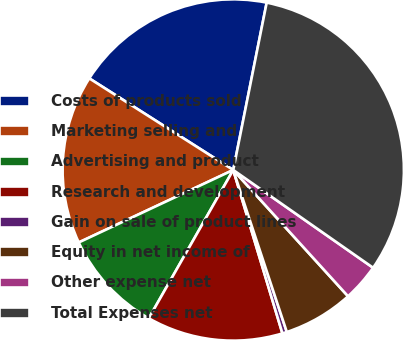<chart> <loc_0><loc_0><loc_500><loc_500><pie_chart><fcel>Costs of products sold<fcel>Marketing selling and<fcel>Advertising and product<fcel>Research and development<fcel>Gain on sale of product lines<fcel>Equity in net income of<fcel>Other expense net<fcel>Total Expenses net<nl><fcel>19.12%<fcel>16.0%<fcel>9.78%<fcel>12.89%<fcel>0.43%<fcel>6.66%<fcel>3.55%<fcel>31.57%<nl></chart> 